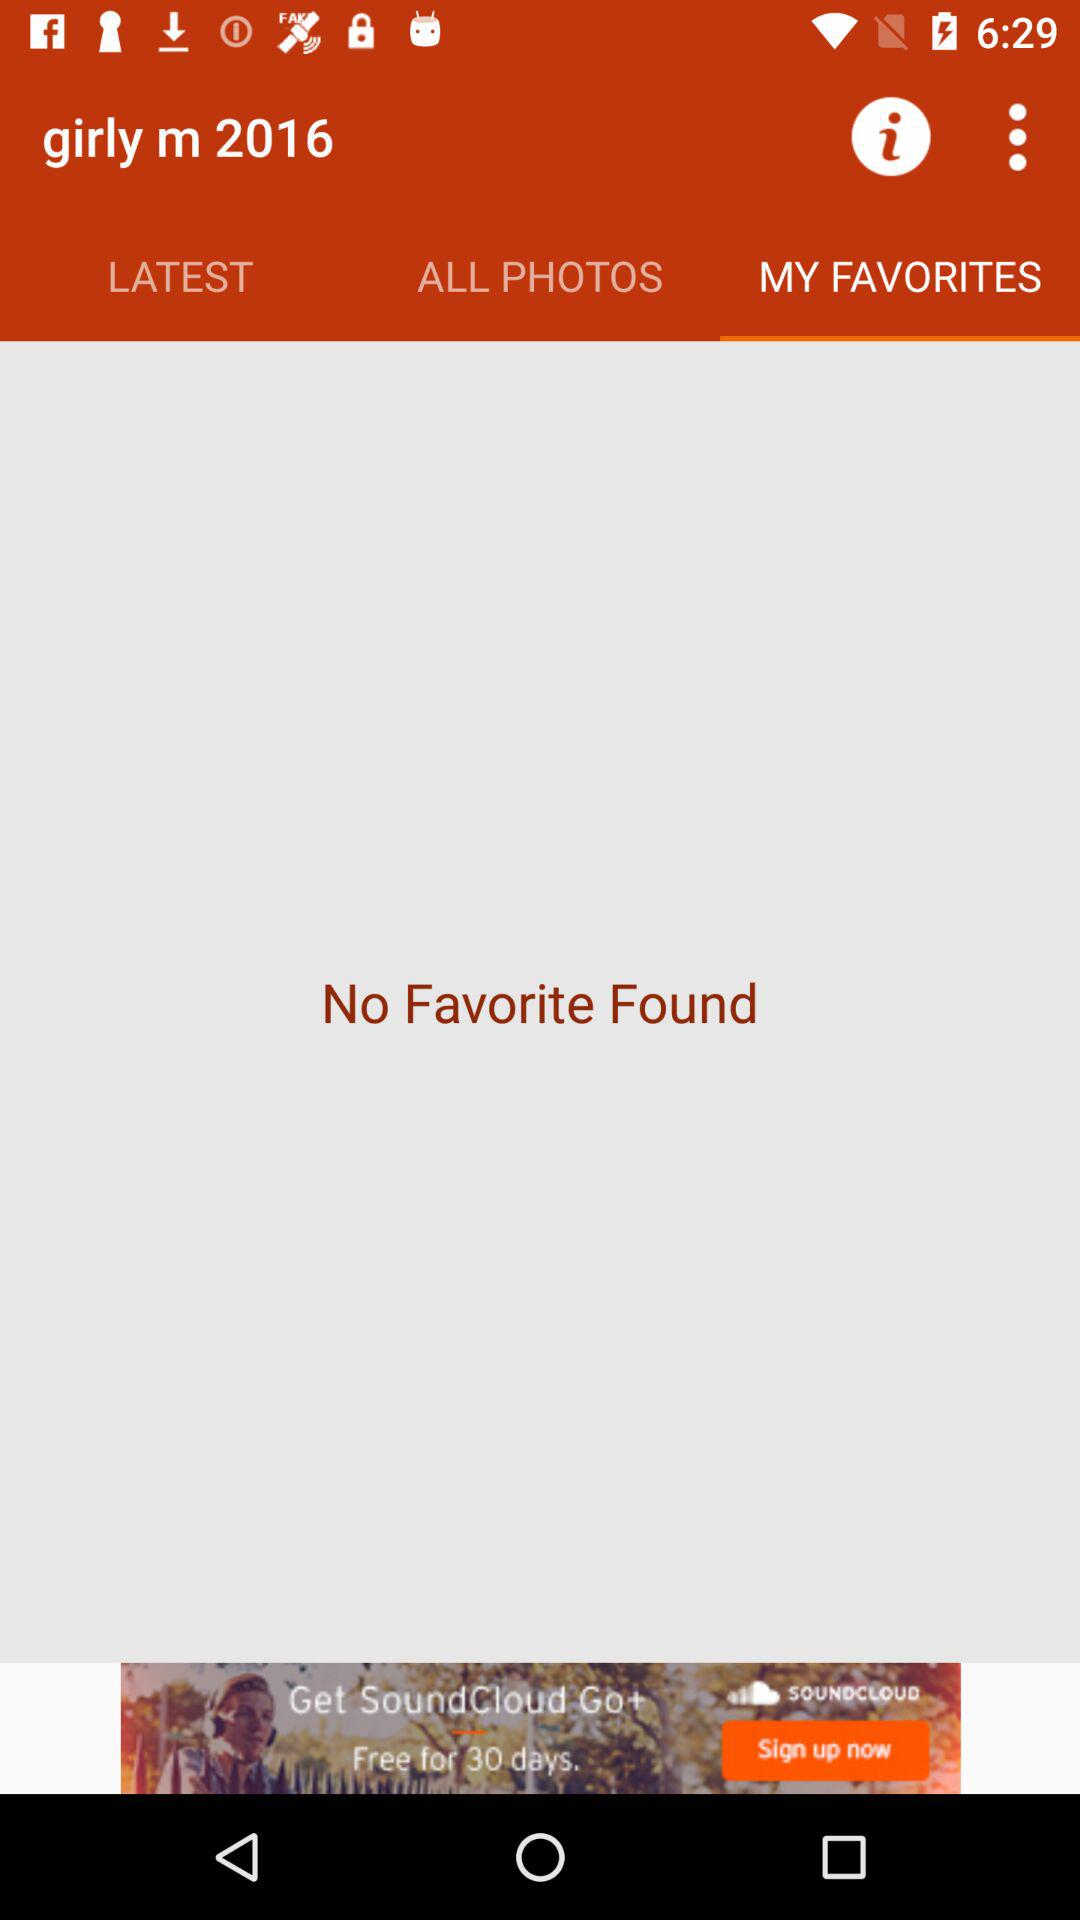Which tab has been selected? The tab "MY FAVORITES" has been selected. 